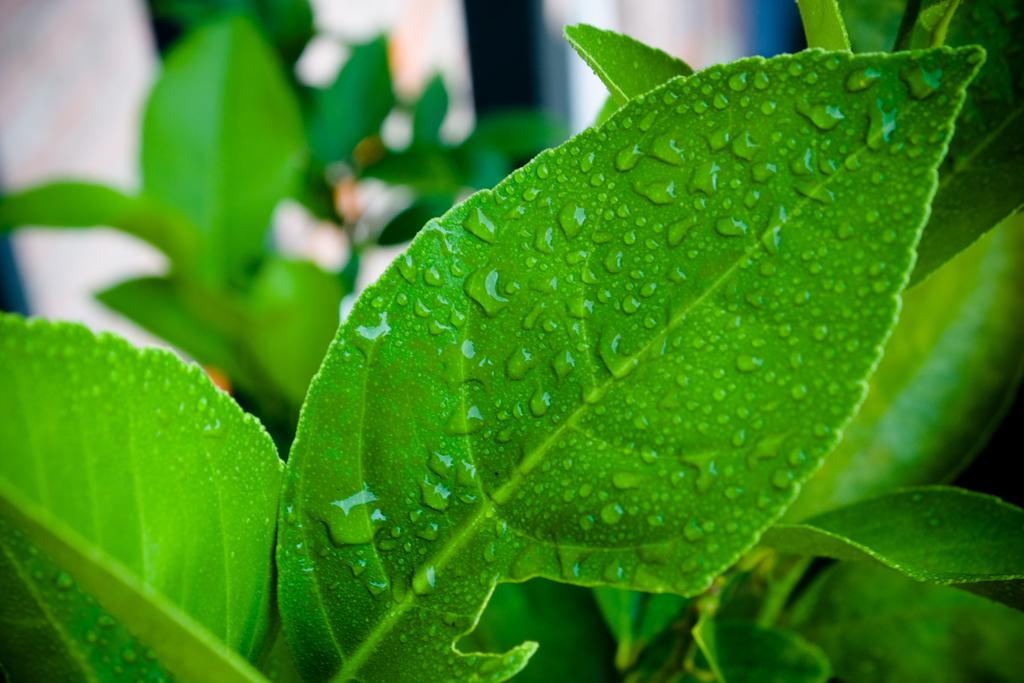What type of vegetation can be seen in the image? There are leaves in the image. Can you describe the condition of the leaves? The leaves have water drops on them. What is the appearance of the background in the image? The background of the image is blurry. Is the grandfather sitting quietly under the trees in the image? There is no grandfather or trees present in the image; it only features leaves with water drops on them. 